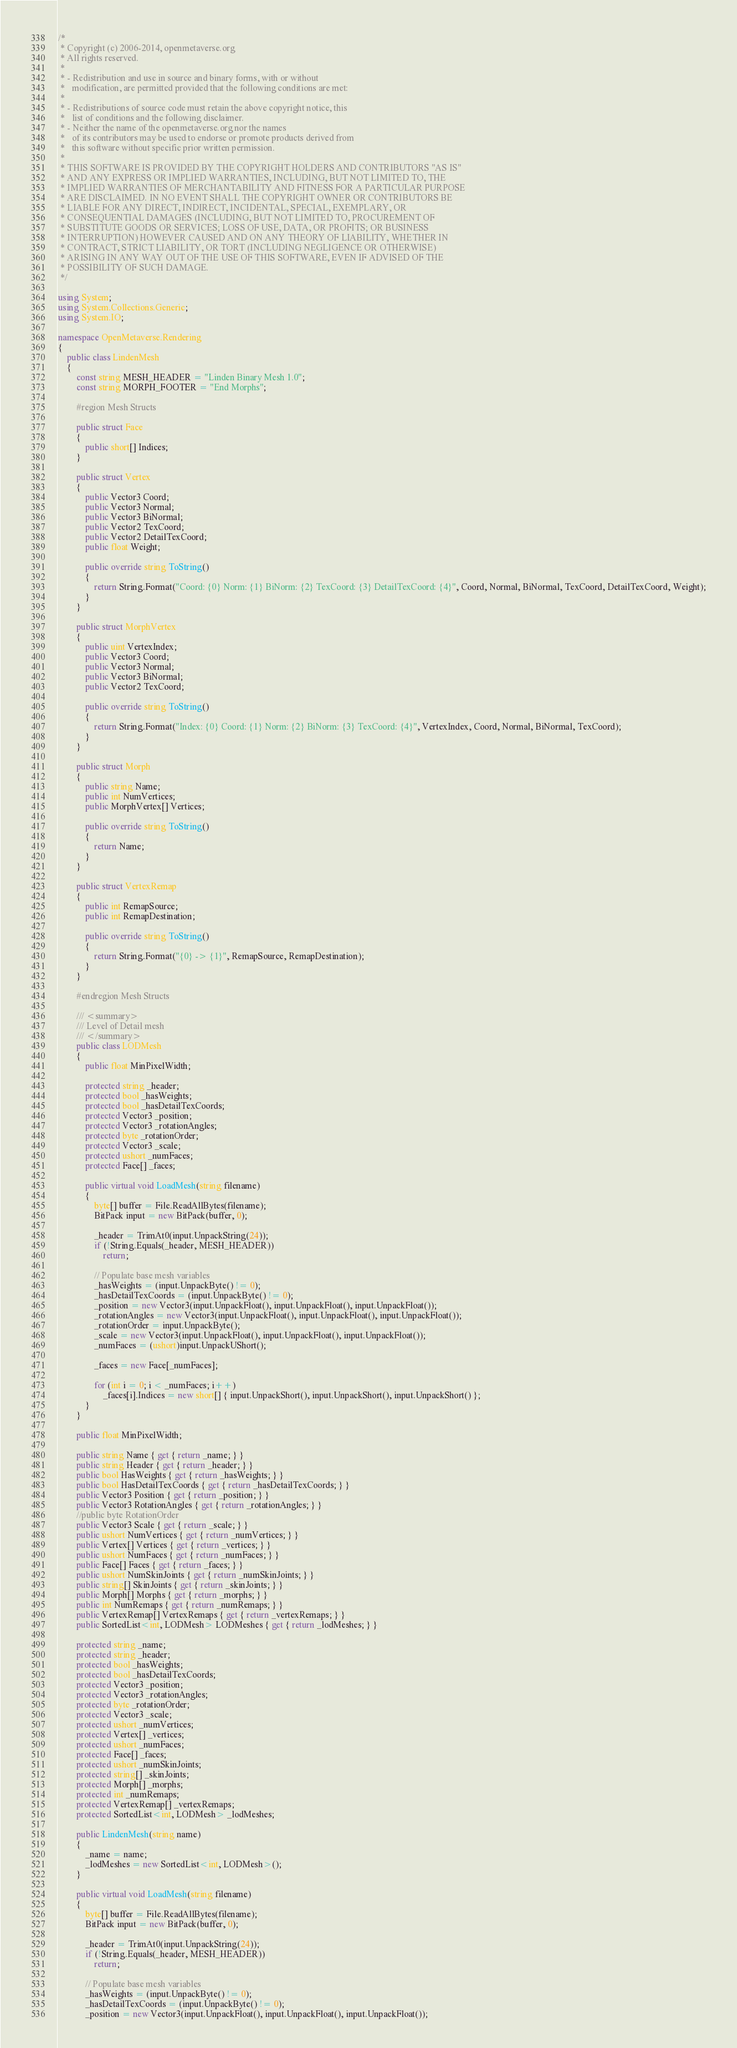Convert code to text. <code><loc_0><loc_0><loc_500><loc_500><_C#_>/*
 * Copyright (c) 2006-2014, openmetaverse.org
 * All rights reserved.
 *
 * - Redistribution and use in source and binary forms, with or without
 *   modification, are permitted provided that the following conditions are met:
 *
 * - Redistributions of source code must retain the above copyright notice, this
 *   list of conditions and the following disclaimer.
 * - Neither the name of the openmetaverse.org nor the names
 *   of its contributors may be used to endorse or promote products derived from
 *   this software without specific prior written permission.
 *
 * THIS SOFTWARE IS PROVIDED BY THE COPYRIGHT HOLDERS AND CONTRIBUTORS "AS IS"
 * AND ANY EXPRESS OR IMPLIED WARRANTIES, INCLUDING, BUT NOT LIMITED TO, THE
 * IMPLIED WARRANTIES OF MERCHANTABILITY AND FITNESS FOR A PARTICULAR PURPOSE
 * ARE DISCLAIMED. IN NO EVENT SHALL THE COPYRIGHT OWNER OR CONTRIBUTORS BE
 * LIABLE FOR ANY DIRECT, INDIRECT, INCIDENTAL, SPECIAL, EXEMPLARY, OR
 * CONSEQUENTIAL DAMAGES (INCLUDING, BUT NOT LIMITED TO, PROCUREMENT OF
 * SUBSTITUTE GOODS OR SERVICES; LOSS OF USE, DATA, OR PROFITS; OR BUSINESS
 * INTERRUPTION) HOWEVER CAUSED AND ON ANY THEORY OF LIABILITY, WHETHER IN
 * CONTRACT, STRICT LIABILITY, OR TORT (INCLUDING NEGLIGENCE OR OTHERWISE)
 * ARISING IN ANY WAY OUT OF THE USE OF THIS SOFTWARE, EVEN IF ADVISED OF THE
 * POSSIBILITY OF SUCH DAMAGE.
 */

using System;
using System.Collections.Generic;
using System.IO;

namespace OpenMetaverse.Rendering
{
    public class LindenMesh
    {
        const string MESH_HEADER = "Linden Binary Mesh 1.0";
        const string MORPH_FOOTER = "End Morphs";

        #region Mesh Structs

        public struct Face
        {
            public short[] Indices;
        }

        public struct Vertex
        {
            public Vector3 Coord;
            public Vector3 Normal;
            public Vector3 BiNormal;
            public Vector2 TexCoord;
            public Vector2 DetailTexCoord;
            public float Weight;

            public override string ToString()
            {
                return String.Format("Coord: {0} Norm: {1} BiNorm: {2} TexCoord: {3} DetailTexCoord: {4}", Coord, Normal, BiNormal, TexCoord, DetailTexCoord, Weight);
            }
        }

        public struct MorphVertex
        {
            public uint VertexIndex;
            public Vector3 Coord;
            public Vector3 Normal;
            public Vector3 BiNormal;
            public Vector2 TexCoord;

            public override string ToString()
            {
                return String.Format("Index: {0} Coord: {1} Norm: {2} BiNorm: {3} TexCoord: {4}", VertexIndex, Coord, Normal, BiNormal, TexCoord);
            }
        }

        public struct Morph
        {
            public string Name;
            public int NumVertices;
            public MorphVertex[] Vertices;

            public override string ToString()
            {
                return Name;
            }
        }

        public struct VertexRemap
        {
            public int RemapSource;
            public int RemapDestination;

            public override string ToString()
            {
                return String.Format("{0} -> {1}", RemapSource, RemapDestination);
            }
        }

        #endregion Mesh Structs

        /// <summary>
        /// Level of Detail mesh
        /// </summary>
        public class LODMesh
        {
            public float MinPixelWidth;

            protected string _header;
            protected bool _hasWeights;
            protected bool _hasDetailTexCoords;
            protected Vector3 _position;
            protected Vector3 _rotationAngles;
            protected byte _rotationOrder;
            protected Vector3 _scale;
            protected ushort _numFaces;
            protected Face[] _faces;

            public virtual void LoadMesh(string filename)
            {
                byte[] buffer = File.ReadAllBytes(filename);
                BitPack input = new BitPack(buffer, 0);

                _header = TrimAt0(input.UnpackString(24));
                if (!String.Equals(_header, MESH_HEADER))
                    return;

                // Populate base mesh variables
                _hasWeights = (input.UnpackByte() != 0);
                _hasDetailTexCoords = (input.UnpackByte() != 0);
                _position = new Vector3(input.UnpackFloat(), input.UnpackFloat(), input.UnpackFloat());
                _rotationAngles = new Vector3(input.UnpackFloat(), input.UnpackFloat(), input.UnpackFloat());
                _rotationOrder = input.UnpackByte();
                _scale = new Vector3(input.UnpackFloat(), input.UnpackFloat(), input.UnpackFloat());
                _numFaces = (ushort)input.UnpackUShort();

                _faces = new Face[_numFaces];

                for (int i = 0; i < _numFaces; i++)
                    _faces[i].Indices = new short[] { input.UnpackShort(), input.UnpackShort(), input.UnpackShort() };
            }
        }

        public float MinPixelWidth;

        public string Name { get { return _name; } }
        public string Header { get { return _header; } }
        public bool HasWeights { get { return _hasWeights; } }
        public bool HasDetailTexCoords { get { return _hasDetailTexCoords; } }
        public Vector3 Position { get { return _position; } }
        public Vector3 RotationAngles { get { return _rotationAngles; } }
        //public byte RotationOrder
        public Vector3 Scale { get { return _scale; } }
        public ushort NumVertices { get { return _numVertices; } }
        public Vertex[] Vertices { get { return _vertices; } }
        public ushort NumFaces { get { return _numFaces; } }
        public Face[] Faces { get { return _faces; } }
        public ushort NumSkinJoints { get { return _numSkinJoints; } }
        public string[] SkinJoints { get { return _skinJoints; } }
        public Morph[] Morphs { get { return _morphs; } }
        public int NumRemaps { get { return _numRemaps; } }
        public VertexRemap[] VertexRemaps { get { return _vertexRemaps; } }
        public SortedList<int, LODMesh> LODMeshes { get { return _lodMeshes; } }

        protected string _name;
        protected string _header;
        protected bool _hasWeights;
        protected bool _hasDetailTexCoords;
        protected Vector3 _position;
        protected Vector3 _rotationAngles;
        protected byte _rotationOrder;
        protected Vector3 _scale;
        protected ushort _numVertices;
        protected Vertex[] _vertices;
        protected ushort _numFaces;
        protected Face[] _faces;
        protected ushort _numSkinJoints;
        protected string[] _skinJoints;
        protected Morph[] _morphs;
        protected int _numRemaps;
        protected VertexRemap[] _vertexRemaps;
        protected SortedList<int, LODMesh> _lodMeshes;

        public LindenMesh(string name)
        {
            _name = name;
            _lodMeshes = new SortedList<int, LODMesh>();
        }

        public virtual void LoadMesh(string filename)
        {
            byte[] buffer = File.ReadAllBytes(filename);
            BitPack input = new BitPack(buffer, 0);

            _header = TrimAt0(input.UnpackString(24));
            if (!String.Equals(_header, MESH_HEADER))
                return;

            // Populate base mesh variables
            _hasWeights = (input.UnpackByte() != 0);
            _hasDetailTexCoords = (input.UnpackByte() != 0);
            _position = new Vector3(input.UnpackFloat(), input.UnpackFloat(), input.UnpackFloat());</code> 